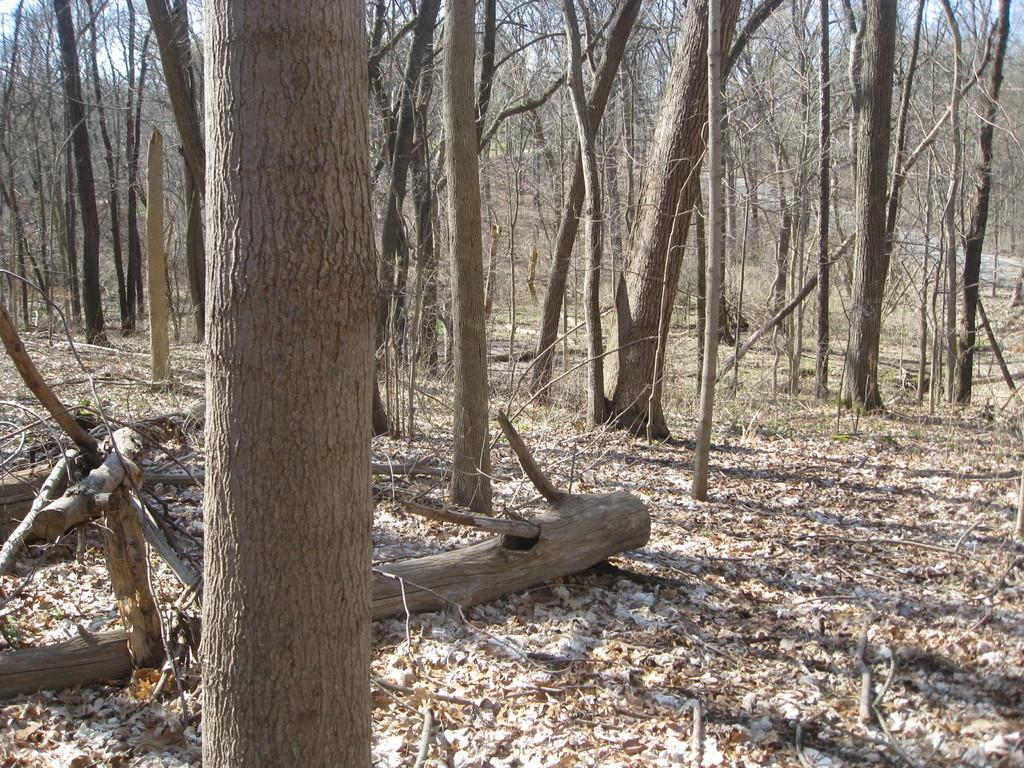What type of vegetation can be seen in the image? There are trees in the image. What part of the trees can be seen in the image? There are leaves in the image. What caption is written on the leaves in the image? There is no caption written on the leaves in the image. What type of furniture can be seen in the image? There is no furniture present in the image; it only features trees and leaves. 